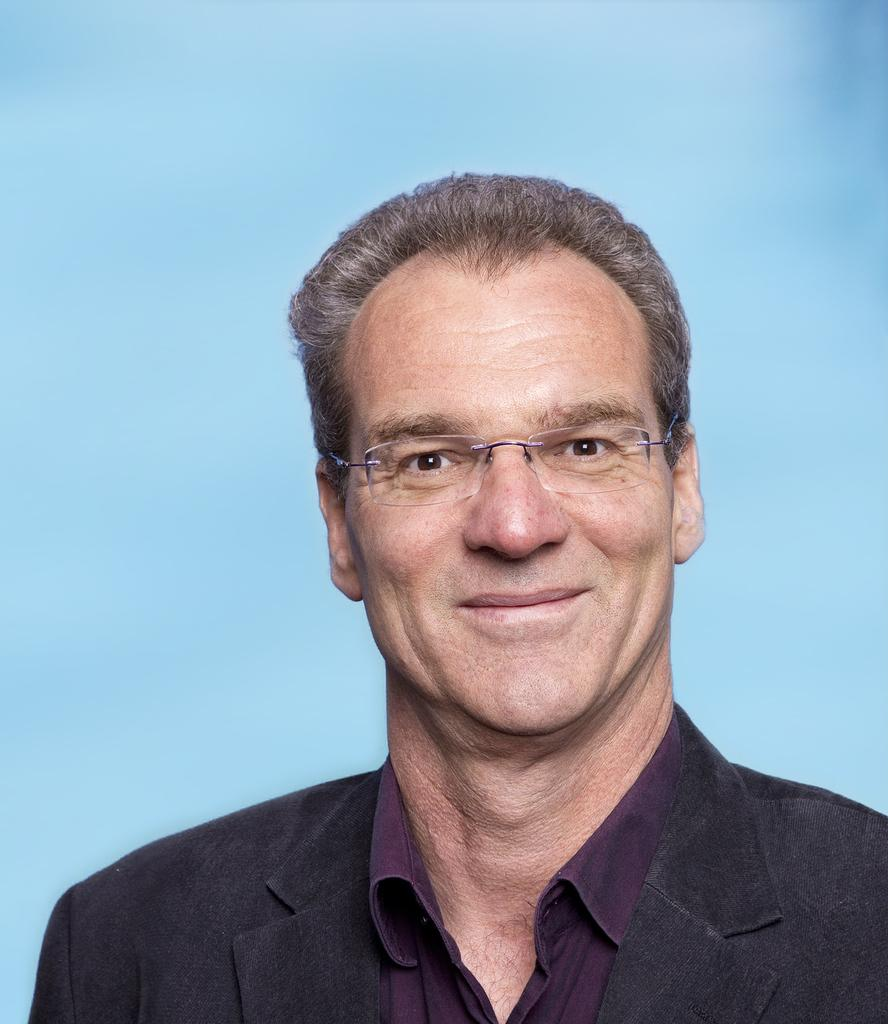Who is present in the image? There is a man in the image. What is the man doing in the image? The man is smiling in the image. What accessories is the man wearing in the image? The man is wearing spectacles in the image. What type of clothing is the man wearing in the image? The man is wearing a suit in the image. What color is the background of the image? The background of the image is blue. What type of shirt is the man's aunt wearing in the image? There is no mention of an aunt or a shirt in the image; it only features a man wearing a suit. 